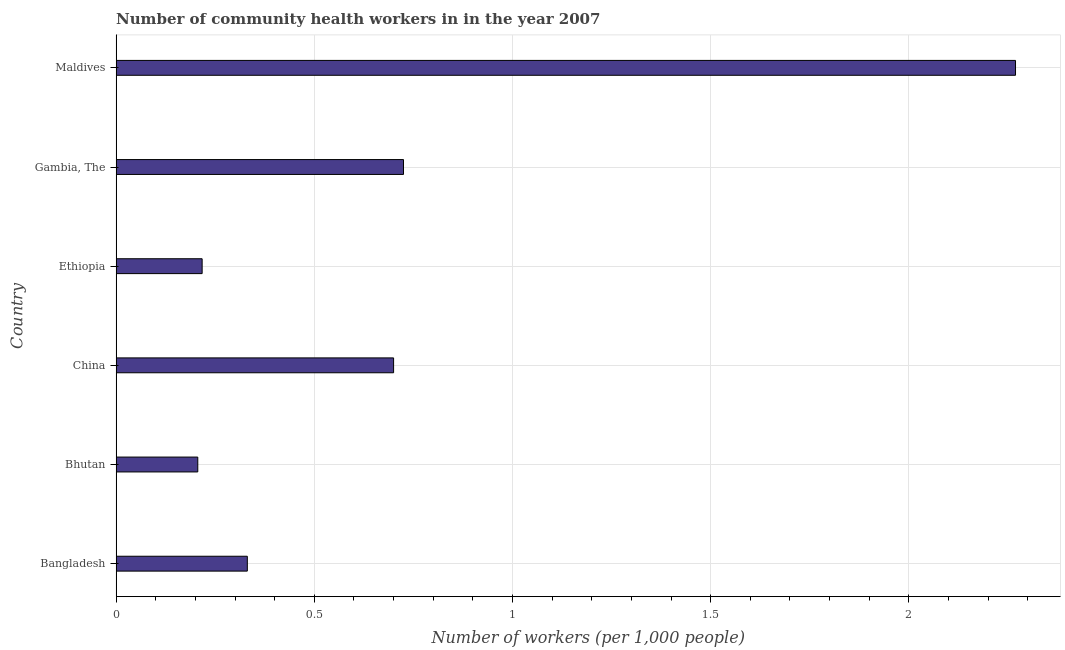Does the graph contain any zero values?
Provide a succinct answer. No. What is the title of the graph?
Offer a terse response. Number of community health workers in in the year 2007. What is the label or title of the X-axis?
Provide a succinct answer. Number of workers (per 1,0 people). What is the label or title of the Y-axis?
Make the answer very short. Country. What is the number of community health workers in Ethiopia?
Provide a short and direct response. 0.22. Across all countries, what is the maximum number of community health workers?
Your response must be concise. 2.27. Across all countries, what is the minimum number of community health workers?
Make the answer very short. 0.21. In which country was the number of community health workers maximum?
Offer a terse response. Maldives. In which country was the number of community health workers minimum?
Keep it short and to the point. Bhutan. What is the sum of the number of community health workers?
Offer a terse response. 4.45. What is the difference between the number of community health workers in Ethiopia and Gambia, The?
Your response must be concise. -0.51. What is the average number of community health workers per country?
Give a very brief answer. 0.74. What is the median number of community health workers?
Provide a short and direct response. 0.52. What is the ratio of the number of community health workers in Bangladesh to that in Maldives?
Your answer should be very brief. 0.15. Is the number of community health workers in Bhutan less than that in Maldives?
Provide a short and direct response. Yes. Is the difference between the number of community health workers in China and Ethiopia greater than the difference between any two countries?
Give a very brief answer. No. What is the difference between the highest and the second highest number of community health workers?
Your response must be concise. 1.54. What is the difference between the highest and the lowest number of community health workers?
Provide a short and direct response. 2.06. In how many countries, is the number of community health workers greater than the average number of community health workers taken over all countries?
Your answer should be compact. 1. Are all the bars in the graph horizontal?
Your answer should be very brief. Yes. What is the Number of workers (per 1,000 people) of Bangladesh?
Provide a short and direct response. 0.33. What is the Number of workers (per 1,000 people) of Bhutan?
Offer a very short reply. 0.21. What is the Number of workers (per 1,000 people) in China?
Give a very brief answer. 0.7. What is the Number of workers (per 1,000 people) in Ethiopia?
Provide a succinct answer. 0.22. What is the Number of workers (per 1,000 people) in Gambia, The?
Your answer should be very brief. 0.72. What is the Number of workers (per 1,000 people) in Maldives?
Ensure brevity in your answer.  2.27. What is the difference between the Number of workers (per 1,000 people) in Bangladesh and Bhutan?
Ensure brevity in your answer.  0.12. What is the difference between the Number of workers (per 1,000 people) in Bangladesh and China?
Offer a very short reply. -0.37. What is the difference between the Number of workers (per 1,000 people) in Bangladesh and Ethiopia?
Provide a short and direct response. 0.11. What is the difference between the Number of workers (per 1,000 people) in Bangladesh and Gambia, The?
Give a very brief answer. -0.39. What is the difference between the Number of workers (per 1,000 people) in Bangladesh and Maldives?
Offer a terse response. -1.94. What is the difference between the Number of workers (per 1,000 people) in Bhutan and China?
Your answer should be compact. -0.49. What is the difference between the Number of workers (per 1,000 people) in Bhutan and Ethiopia?
Keep it short and to the point. -0.01. What is the difference between the Number of workers (per 1,000 people) in Bhutan and Gambia, The?
Offer a very short reply. -0.52. What is the difference between the Number of workers (per 1,000 people) in Bhutan and Maldives?
Provide a short and direct response. -2.06. What is the difference between the Number of workers (per 1,000 people) in China and Ethiopia?
Offer a terse response. 0.48. What is the difference between the Number of workers (per 1,000 people) in China and Gambia, The?
Ensure brevity in your answer.  -0.03. What is the difference between the Number of workers (per 1,000 people) in China and Maldives?
Ensure brevity in your answer.  -1.57. What is the difference between the Number of workers (per 1,000 people) in Ethiopia and Gambia, The?
Make the answer very short. -0.51. What is the difference between the Number of workers (per 1,000 people) in Ethiopia and Maldives?
Give a very brief answer. -2.05. What is the difference between the Number of workers (per 1,000 people) in Gambia, The and Maldives?
Offer a very short reply. -1.54. What is the ratio of the Number of workers (per 1,000 people) in Bangladesh to that in Bhutan?
Your answer should be compact. 1.61. What is the ratio of the Number of workers (per 1,000 people) in Bangladesh to that in China?
Give a very brief answer. 0.47. What is the ratio of the Number of workers (per 1,000 people) in Bangladesh to that in Ethiopia?
Your response must be concise. 1.52. What is the ratio of the Number of workers (per 1,000 people) in Bangladesh to that in Gambia, The?
Your answer should be very brief. 0.46. What is the ratio of the Number of workers (per 1,000 people) in Bangladesh to that in Maldives?
Provide a succinct answer. 0.15. What is the ratio of the Number of workers (per 1,000 people) in Bhutan to that in China?
Provide a succinct answer. 0.29. What is the ratio of the Number of workers (per 1,000 people) in Bhutan to that in Ethiopia?
Ensure brevity in your answer.  0.95. What is the ratio of the Number of workers (per 1,000 people) in Bhutan to that in Gambia, The?
Your response must be concise. 0.28. What is the ratio of the Number of workers (per 1,000 people) in Bhutan to that in Maldives?
Provide a succinct answer. 0.09. What is the ratio of the Number of workers (per 1,000 people) in China to that in Ethiopia?
Your answer should be very brief. 3.23. What is the ratio of the Number of workers (per 1,000 people) in China to that in Maldives?
Ensure brevity in your answer.  0.31. What is the ratio of the Number of workers (per 1,000 people) in Ethiopia to that in Gambia, The?
Ensure brevity in your answer.  0.3. What is the ratio of the Number of workers (per 1,000 people) in Ethiopia to that in Maldives?
Make the answer very short. 0.1. What is the ratio of the Number of workers (per 1,000 people) in Gambia, The to that in Maldives?
Offer a very short reply. 0.32. 